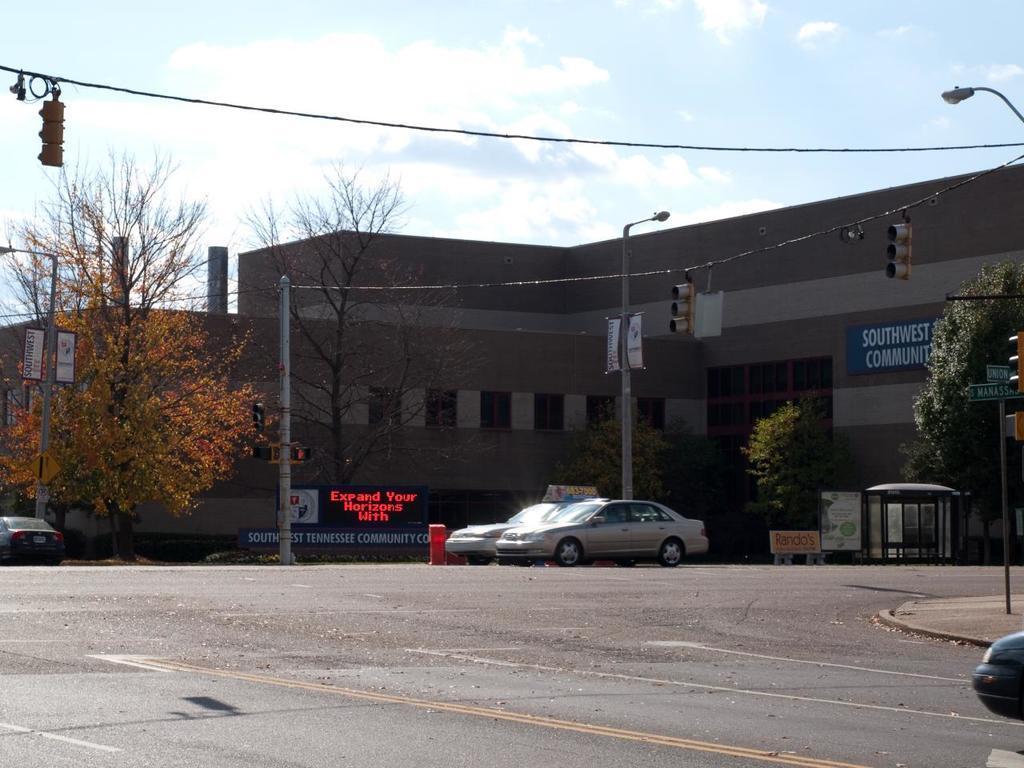Could you give a brief overview of what you see in this image? At the bottom this is the road, in the middle few cars are there on the road. On the left side there are trees, this is the building in this image. At the top it is the sky. 